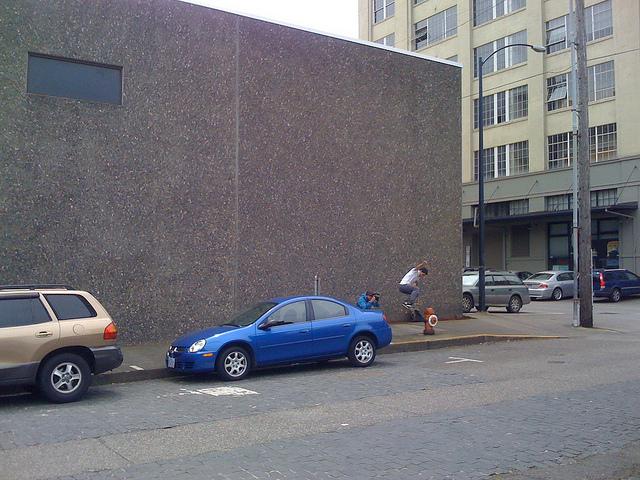How are the cars similar?
Keep it brief. Parked. What color is the car?
Give a very brief answer. Blue. What is in front of the car?
Keep it brief. Car. IS there a blue car in the picture?
Short answer required. Yes. What is beneath the car?
Keep it brief. Pavement. What is the make of the car?
Keep it brief. Toyota. Are all the cars in this photo parked?
Short answer required. Yes. What color is the fire hydrant?
Give a very brief answer. Red. How many cars can be seen?
Concise answer only. 5. Should this person be written more than one parking violation?
Be succinct. No. Are trees visible?
Be succinct. No. 